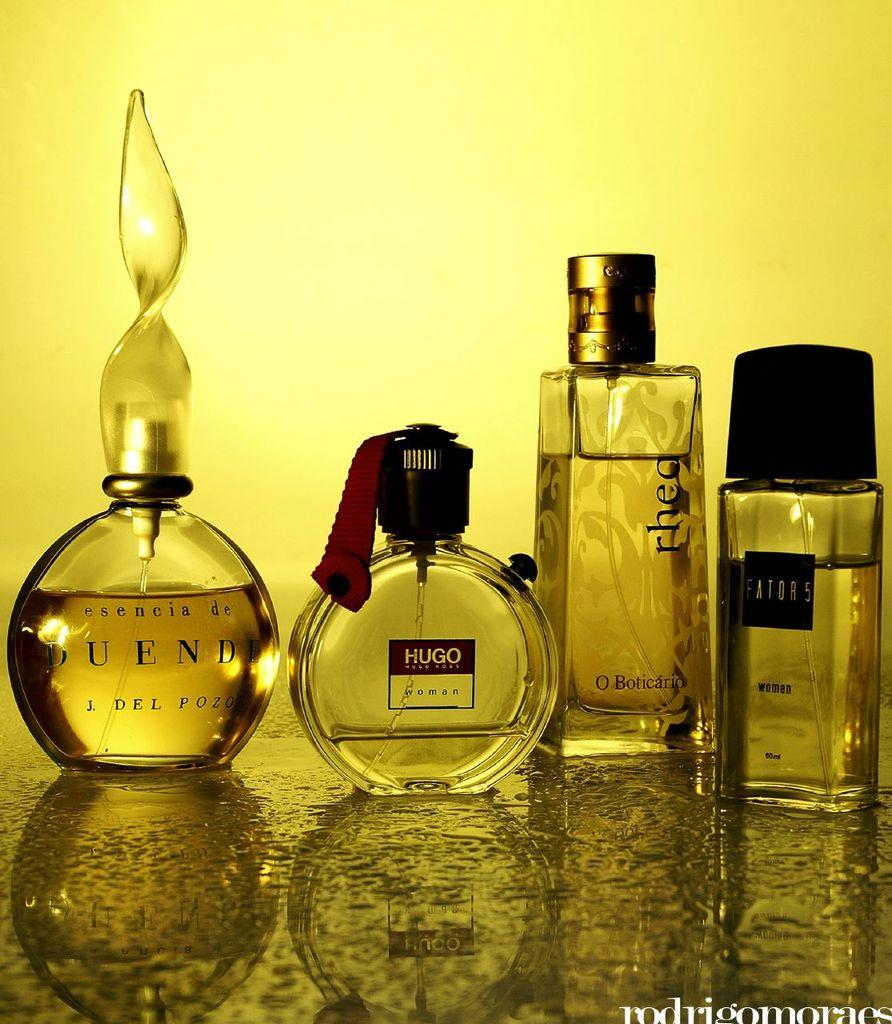<image>
Offer a succinct explanation of the picture presented. Various bottles of cologne sit on a table like Hugo and Duende 